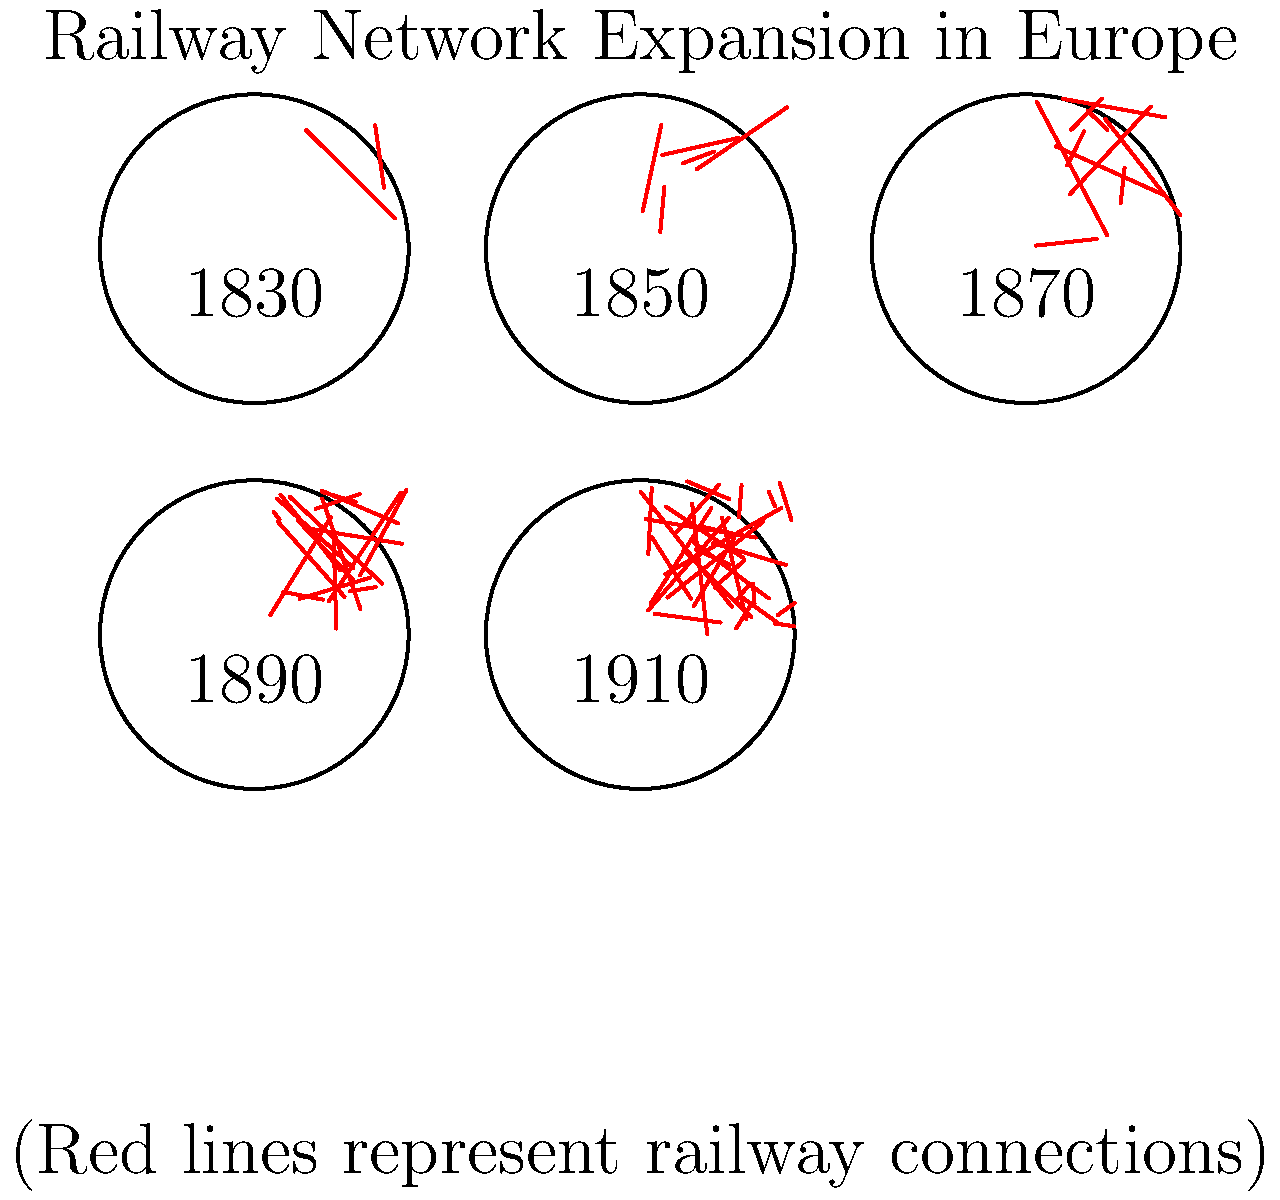Based on the series of maps depicting the expansion of railway networks across Europe from 1830 to 1910, calculate the average rate of increase in railway connections per decade. Round your answer to the nearest whole number. To solve this problem, we'll follow these steps:

1. Identify the number of railway connections for each year:
   1830: 2 connections
   1850: 5 connections
   1870: 10 connections
   1890: 18 connections
   1910: 30 connections

2. Calculate the total increase in railway connections:
   Total increase = Final connections - Initial connections
   Total increase = 30 - 2 = 28 connections

3. Determine the time span:
   Time span = 1910 - 1830 = 80 years

4. Convert the time span to decades:
   Number of decades = 80 years ÷ 10 years/decade = 8 decades

5. Calculate the average rate of increase per decade:
   Average rate = Total increase ÷ Number of decades
   Average rate = 28 connections ÷ 8 decades = 3.5 connections/decade

6. Round to the nearest whole number:
   3.5 rounds to 4

Therefore, the average rate of increase in railway connections per decade, rounded to the nearest whole number, is 4 connections/decade.
Answer: 4 connections/decade 